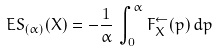Convert formula to latex. <formula><loc_0><loc_0><loc_500><loc_500>E S _ { ( \alpha ) } ( X ) = - \frac { 1 } { \alpha } \, \int _ { 0 } ^ { \alpha } F _ { X } ^ { \leftarrow } ( p ) \, d p</formula> 